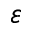<formula> <loc_0><loc_0><loc_500><loc_500>\varepsilon</formula> 